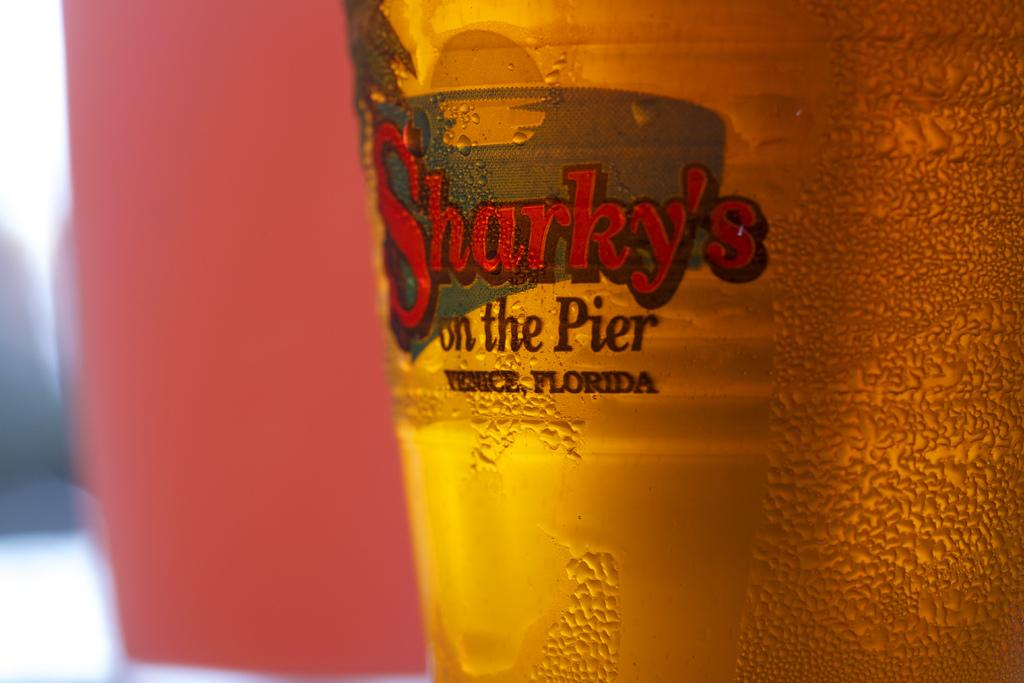<image>
Create a compact narrative representing the image presented. Sharky's beer is displaced and says it's on the pier 